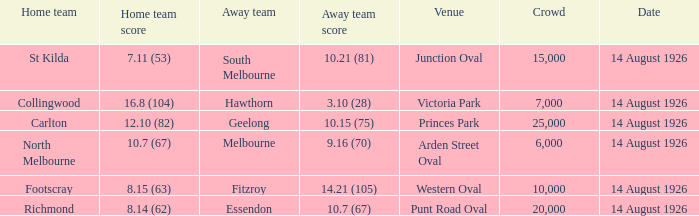What is the combined attendance of all home games for north melbourne? 6000.0. 